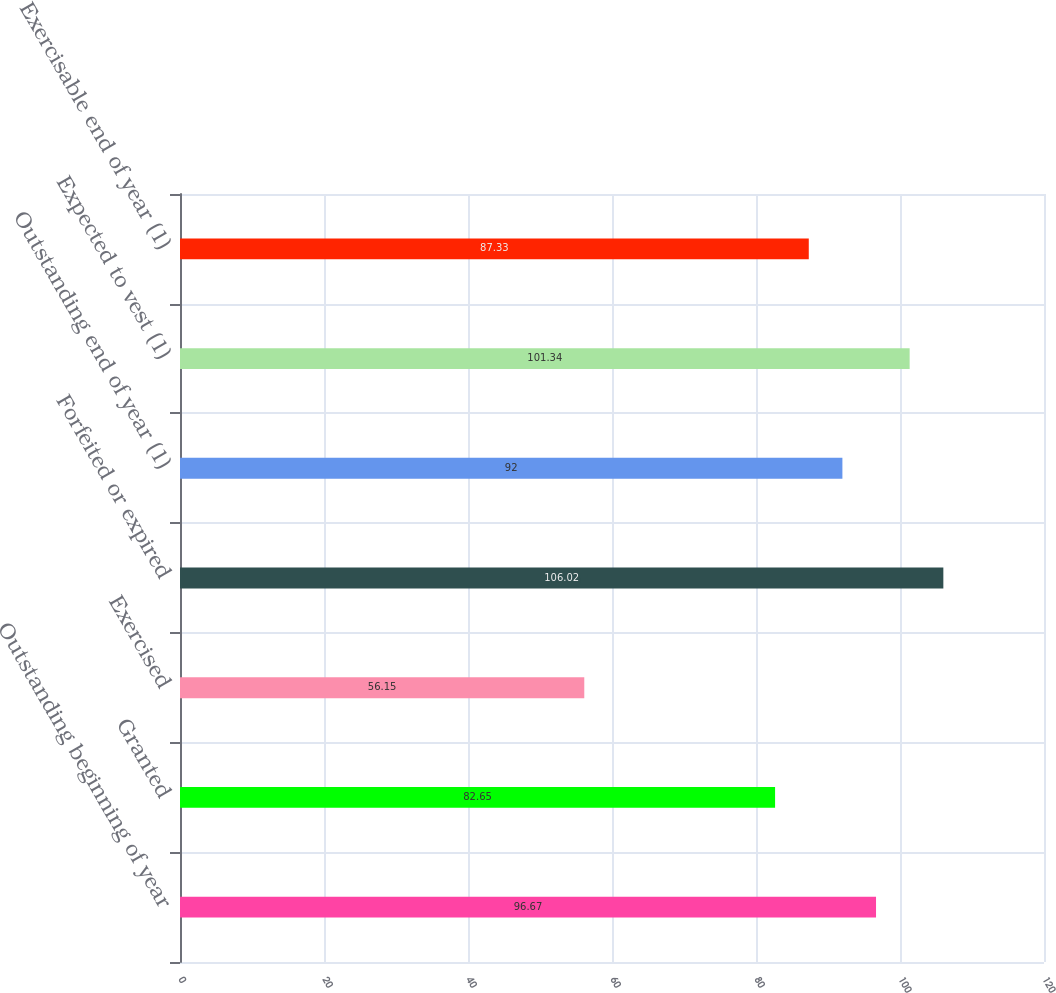<chart> <loc_0><loc_0><loc_500><loc_500><bar_chart><fcel>Outstanding beginning of year<fcel>Granted<fcel>Exercised<fcel>Forfeited or expired<fcel>Outstanding end of year (1)<fcel>Expected to vest (1)<fcel>Exercisable end of year (1)<nl><fcel>96.67<fcel>82.65<fcel>56.15<fcel>106.02<fcel>92<fcel>101.34<fcel>87.33<nl></chart> 